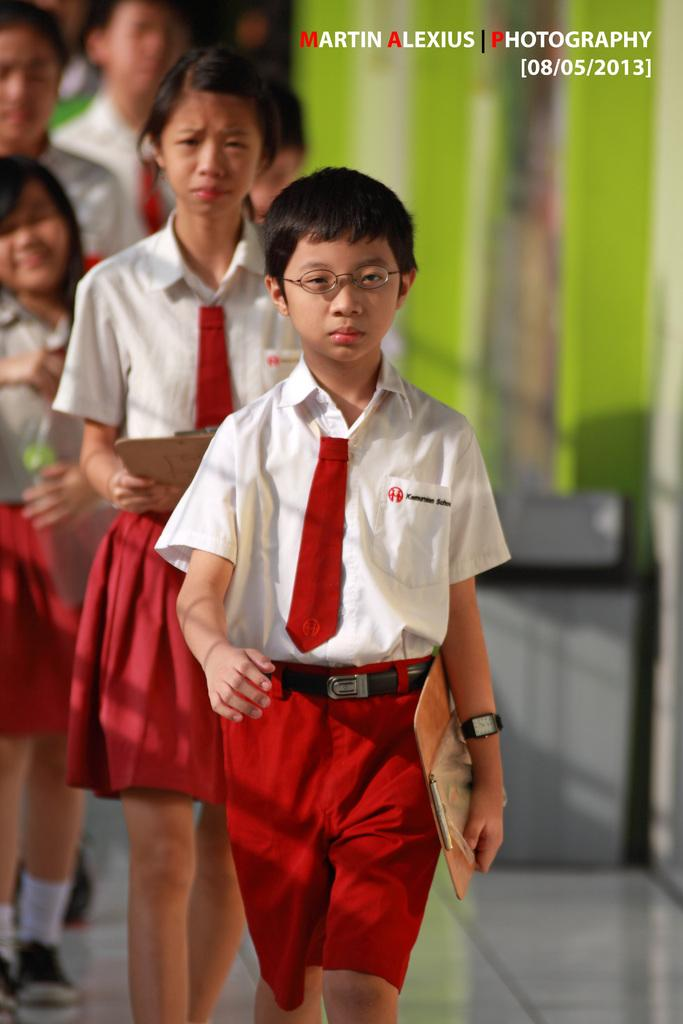What is happening in the image? There is a group of people standing in the image. What are some of the people in the image doing? Three persons are holding objects in the image. Can you describe the background of the image? The background of the image is blurred. Is there any additional information or markings on the image? Yes, there is a watermark on the image. What type of bread is being discussed by the group in the image? There is no indication of a discussion about bread in the image, nor is there any visible bread. 